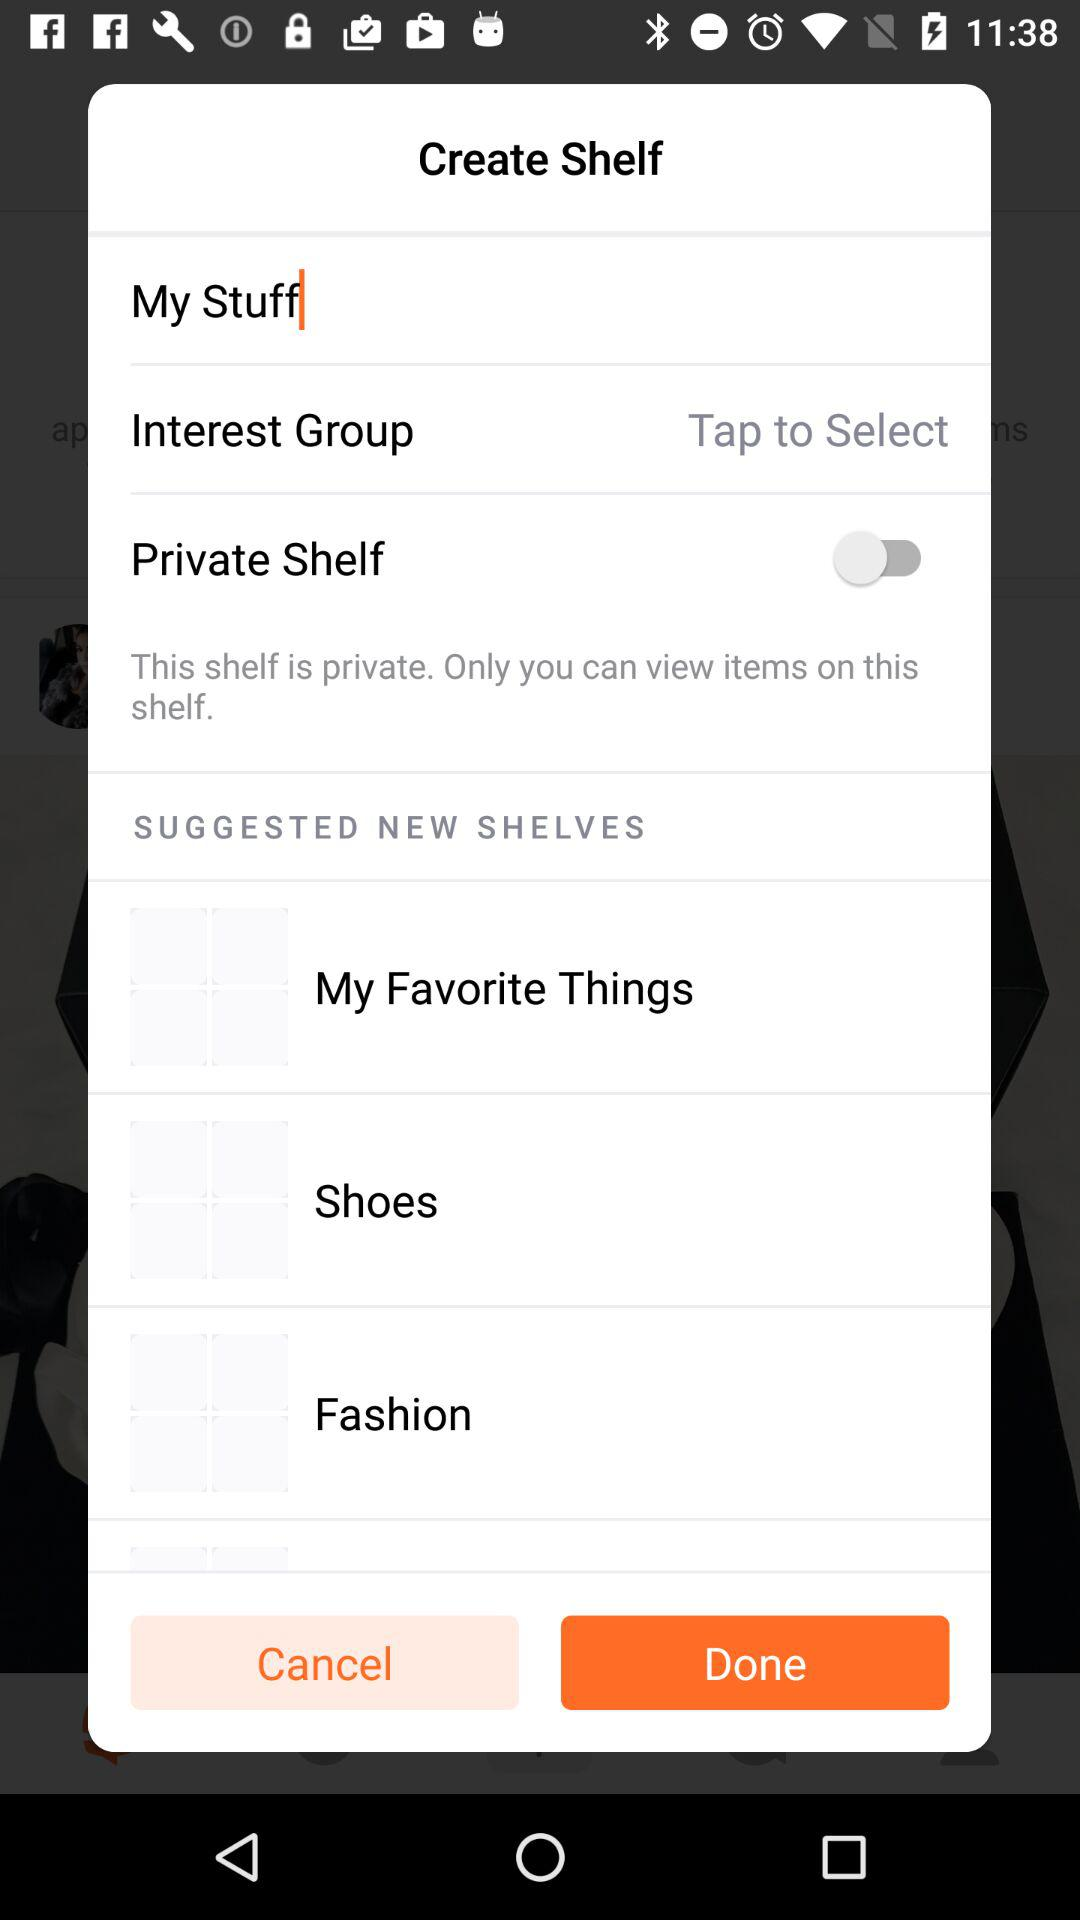What is the status of the "Private Shelf"? The status is "off". 